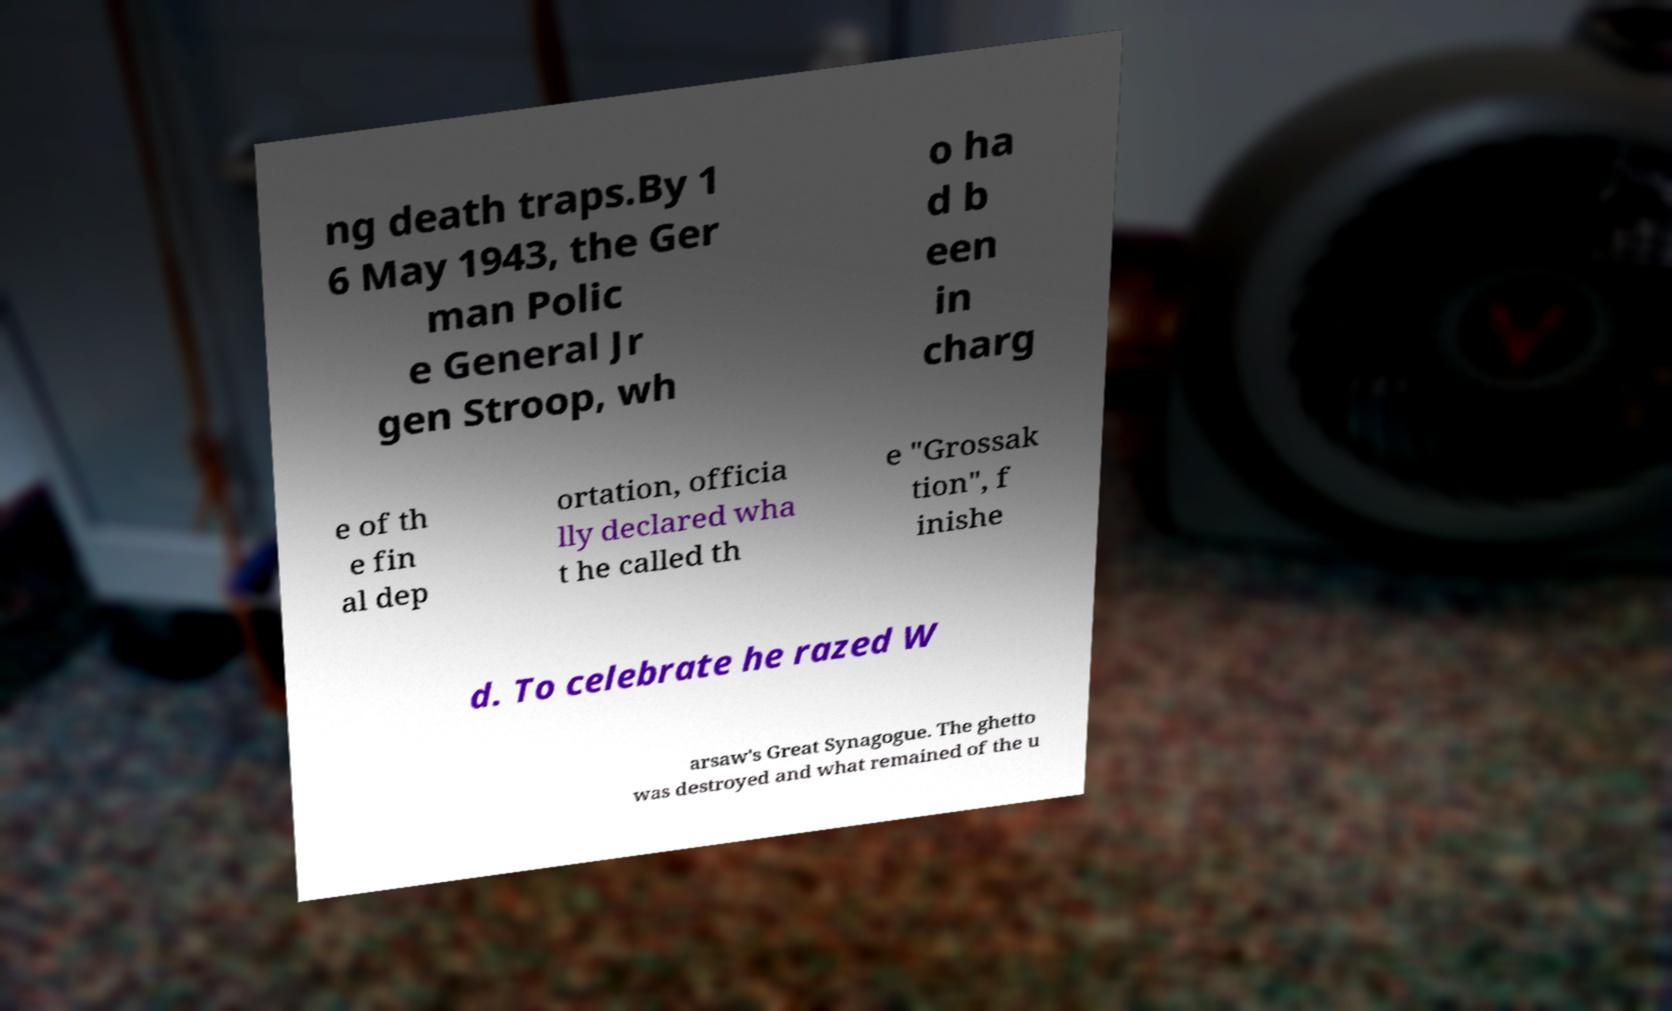Please read and relay the text visible in this image. What does it say? ng death traps.By 1 6 May 1943, the Ger man Polic e General Jr gen Stroop, wh o ha d b een in charg e of th e fin al dep ortation, officia lly declared wha t he called th e "Grossak tion", f inishe d. To celebrate he razed W arsaw's Great Synagogue. The ghetto was destroyed and what remained of the u 